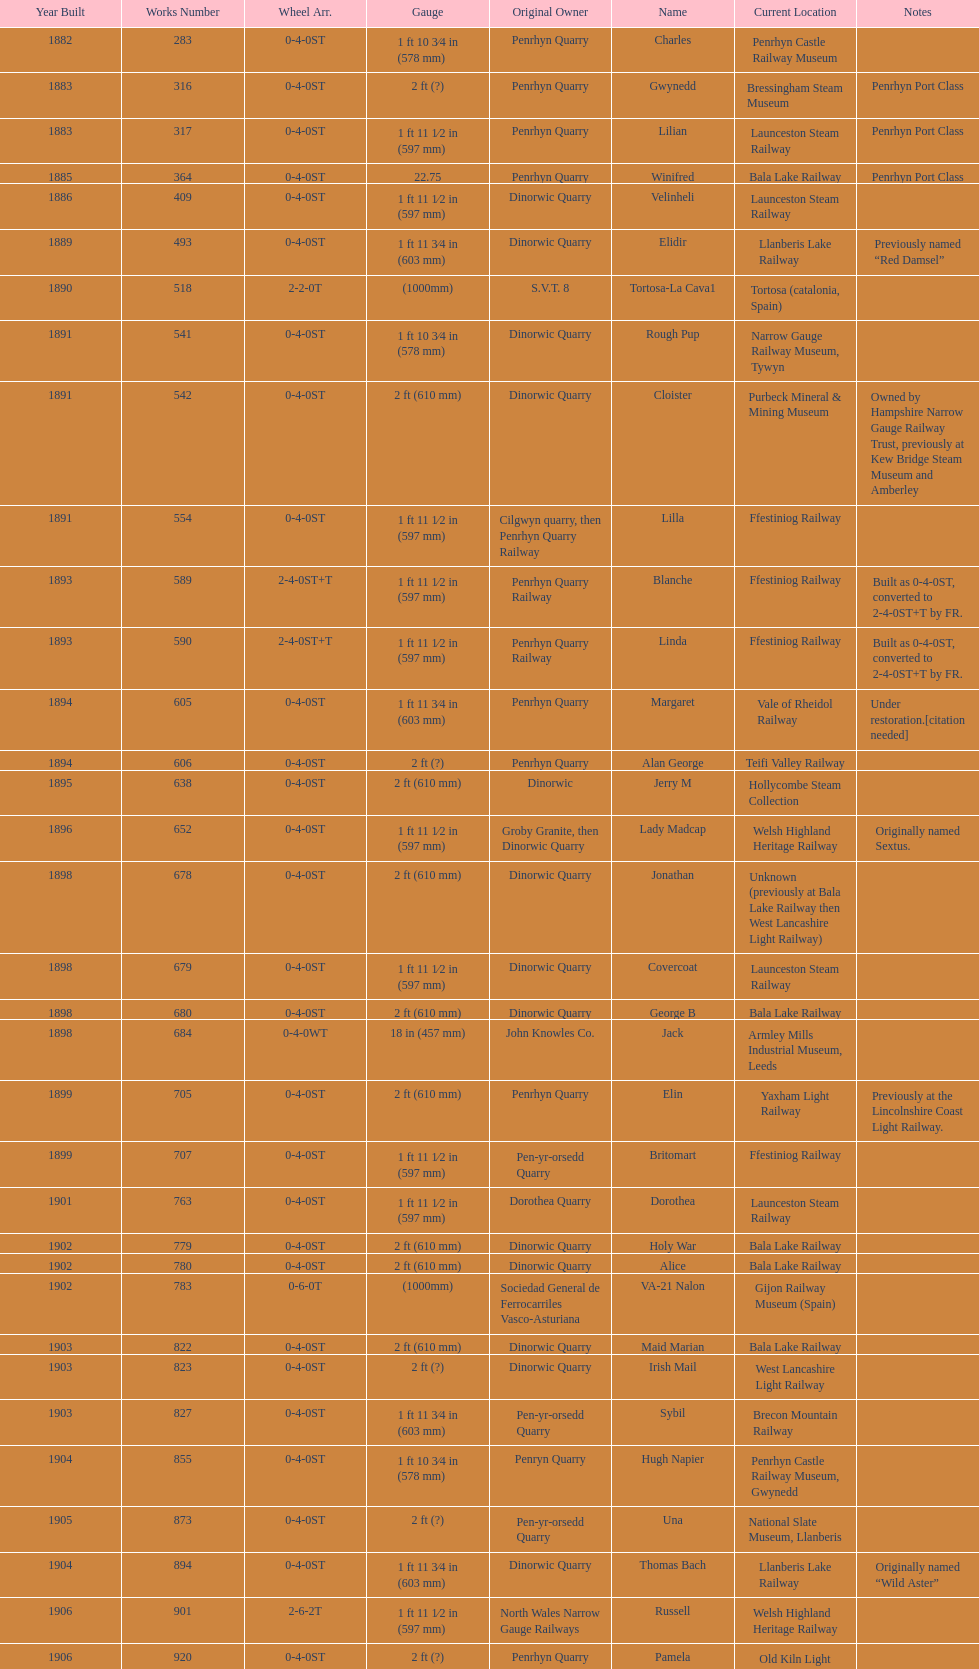How many steam engines are presently situated at the bala lake railway? 364. 